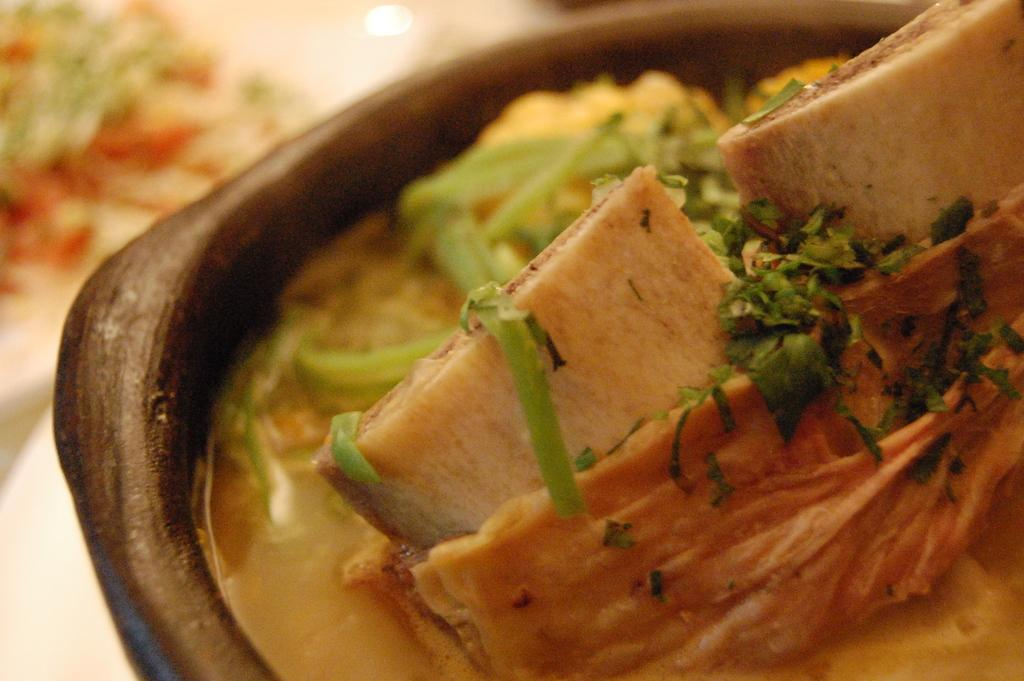What is in the bowl that is visible in the image? There is a bowl containing food in the image. Where is the bowl located in the image? The bowl is placed on a surface. What else can be seen on the surface in the image? There is food placed on a plate on the left side of the image. Is there a slope visible in the image? No, there is no slope visible in the image. What type of home is depicted in the image? The image does not depict a home; it only shows a bowl containing food and a plate with food on the left side. 